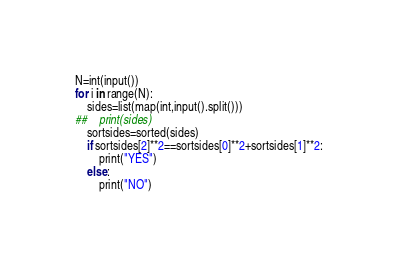<code> <loc_0><loc_0><loc_500><loc_500><_Python_>N=int(input())
for i in range(N):
    sides=list(map(int,input().split()))
##    print(sides)
    sortsides=sorted(sides)
    if sortsides[2]**2==sortsides[0]**2+sortsides[1]**2:
        print("YES")
    else:
        print("NO")

</code> 